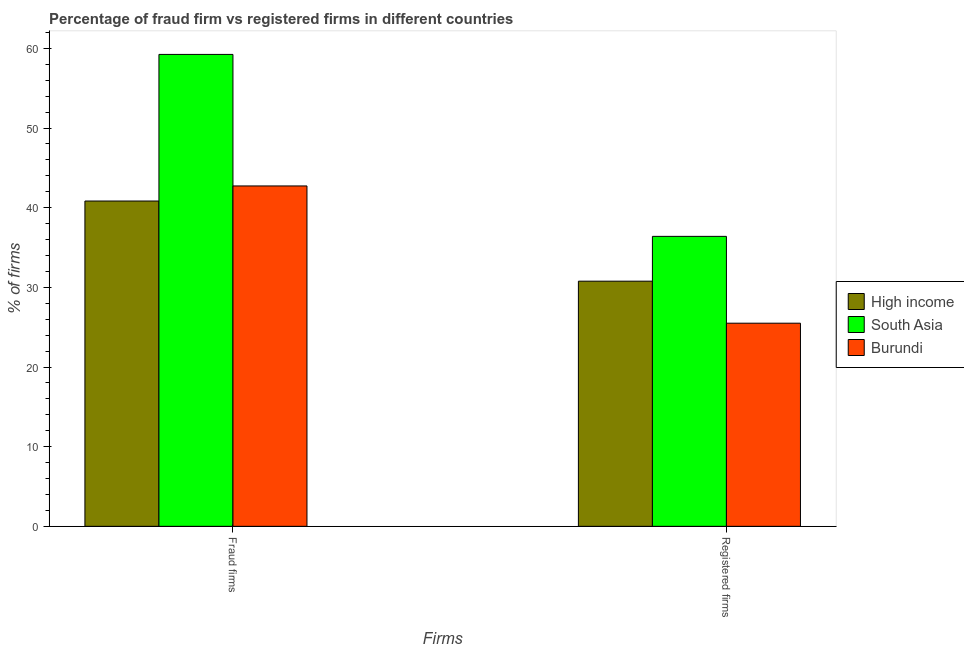How many bars are there on the 2nd tick from the left?
Offer a terse response. 3. What is the label of the 2nd group of bars from the left?
Provide a short and direct response. Registered firms. What is the percentage of registered firms in South Asia?
Make the answer very short. 36.4. Across all countries, what is the maximum percentage of registered firms?
Your answer should be very brief. 36.4. In which country was the percentage of fraud firms maximum?
Make the answer very short. South Asia. In which country was the percentage of fraud firms minimum?
Keep it short and to the point. High income. What is the total percentage of fraud firms in the graph?
Offer a very short reply. 142.81. What is the difference between the percentage of registered firms in High income and that in South Asia?
Provide a short and direct response. -5.62. What is the difference between the percentage of registered firms in South Asia and the percentage of fraud firms in High income?
Ensure brevity in your answer.  -4.44. What is the average percentage of registered firms per country?
Ensure brevity in your answer.  30.89. What is the difference between the percentage of registered firms and percentage of fraud firms in South Asia?
Ensure brevity in your answer.  -22.84. In how many countries, is the percentage of fraud firms greater than 40 %?
Ensure brevity in your answer.  3. What is the ratio of the percentage of registered firms in Burundi to that in South Asia?
Provide a succinct answer. 0.7. Is the percentage of registered firms in South Asia less than that in Burundi?
Make the answer very short. No. What does the 2nd bar from the left in Fraud firms represents?
Give a very brief answer. South Asia. What does the 1st bar from the right in Fraud firms represents?
Give a very brief answer. Burundi. How many bars are there?
Your response must be concise. 6. How many countries are there in the graph?
Keep it short and to the point. 3. How are the legend labels stacked?
Offer a terse response. Vertical. What is the title of the graph?
Offer a very short reply. Percentage of fraud firm vs registered firms in different countries. Does "Djibouti" appear as one of the legend labels in the graph?
Provide a succinct answer. No. What is the label or title of the X-axis?
Your answer should be compact. Firms. What is the label or title of the Y-axis?
Your response must be concise. % of firms. What is the % of firms of High income in Fraud firms?
Keep it short and to the point. 40.84. What is the % of firms in South Asia in Fraud firms?
Give a very brief answer. 59.24. What is the % of firms in Burundi in Fraud firms?
Keep it short and to the point. 42.73. What is the % of firms of High income in Registered firms?
Make the answer very short. 30.77. What is the % of firms in South Asia in Registered firms?
Your answer should be compact. 36.4. What is the % of firms of Burundi in Registered firms?
Offer a terse response. 25.5. Across all Firms, what is the maximum % of firms of High income?
Offer a terse response. 40.84. Across all Firms, what is the maximum % of firms in South Asia?
Provide a succinct answer. 59.24. Across all Firms, what is the maximum % of firms in Burundi?
Provide a short and direct response. 42.73. Across all Firms, what is the minimum % of firms of High income?
Your answer should be compact. 30.77. Across all Firms, what is the minimum % of firms in South Asia?
Provide a short and direct response. 36.4. Across all Firms, what is the minimum % of firms in Burundi?
Keep it short and to the point. 25.5. What is the total % of firms in High income in the graph?
Your answer should be compact. 71.61. What is the total % of firms in South Asia in the graph?
Your answer should be very brief. 95.64. What is the total % of firms in Burundi in the graph?
Your answer should be very brief. 68.23. What is the difference between the % of firms of High income in Fraud firms and that in Registered firms?
Your response must be concise. 10.06. What is the difference between the % of firms in South Asia in Fraud firms and that in Registered firms?
Give a very brief answer. 22.84. What is the difference between the % of firms in Burundi in Fraud firms and that in Registered firms?
Your response must be concise. 17.23. What is the difference between the % of firms in High income in Fraud firms and the % of firms in South Asia in Registered firms?
Give a very brief answer. 4.44. What is the difference between the % of firms in High income in Fraud firms and the % of firms in Burundi in Registered firms?
Offer a terse response. 15.34. What is the difference between the % of firms in South Asia in Fraud firms and the % of firms in Burundi in Registered firms?
Keep it short and to the point. 33.74. What is the average % of firms in High income per Firms?
Make the answer very short. 35.81. What is the average % of firms in South Asia per Firms?
Your answer should be very brief. 47.82. What is the average % of firms in Burundi per Firms?
Ensure brevity in your answer.  34.12. What is the difference between the % of firms of High income and % of firms of South Asia in Fraud firms?
Your response must be concise. -18.4. What is the difference between the % of firms of High income and % of firms of Burundi in Fraud firms?
Offer a very short reply. -1.89. What is the difference between the % of firms of South Asia and % of firms of Burundi in Fraud firms?
Offer a terse response. 16.51. What is the difference between the % of firms in High income and % of firms in South Asia in Registered firms?
Offer a very short reply. -5.62. What is the difference between the % of firms of High income and % of firms of Burundi in Registered firms?
Keep it short and to the point. 5.28. What is the difference between the % of firms of South Asia and % of firms of Burundi in Registered firms?
Keep it short and to the point. 10.9. What is the ratio of the % of firms of High income in Fraud firms to that in Registered firms?
Offer a very short reply. 1.33. What is the ratio of the % of firms in South Asia in Fraud firms to that in Registered firms?
Provide a short and direct response. 1.63. What is the ratio of the % of firms in Burundi in Fraud firms to that in Registered firms?
Your answer should be compact. 1.68. What is the difference between the highest and the second highest % of firms of High income?
Ensure brevity in your answer.  10.06. What is the difference between the highest and the second highest % of firms of South Asia?
Your response must be concise. 22.84. What is the difference between the highest and the second highest % of firms of Burundi?
Make the answer very short. 17.23. What is the difference between the highest and the lowest % of firms of High income?
Provide a succinct answer. 10.06. What is the difference between the highest and the lowest % of firms in South Asia?
Provide a short and direct response. 22.84. What is the difference between the highest and the lowest % of firms in Burundi?
Offer a very short reply. 17.23. 